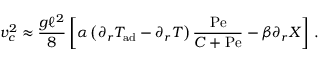Convert formula to latex. <formula><loc_0><loc_0><loc_500><loc_500>v _ { c } ^ { 2 } \approx \frac { g \ell ^ { 2 } } { 8 } \left [ \alpha \left ( \partial _ { r } T _ { a d } - \partial _ { r } T \right ) { \frac { P e } { C + P e } } - \beta \partial _ { r } X \right ] \, .</formula> 